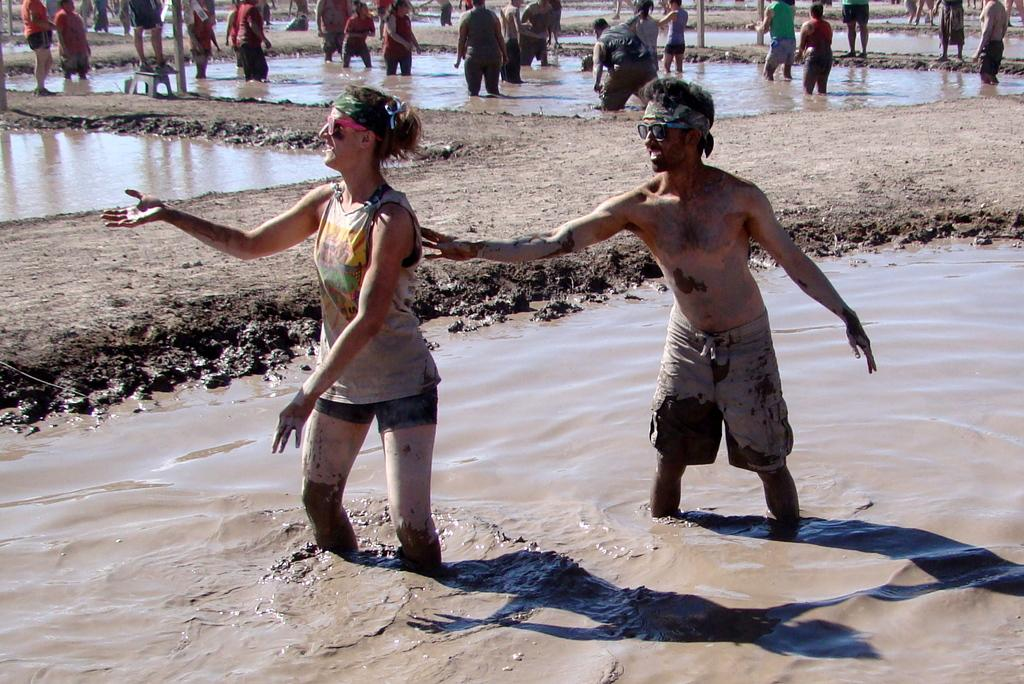What are the people in the image doing? The people in the image are standing in the mud. How can you describe the clothing of the people in the image? The people are wearing different color dresses. What accessory are the people wearing in the image? The people are wearing glasses. What can be seen in the background of the image? There is water visible in the image. What objects are present in the image besides the people? There are poles and a stool in the image. What type of vacation is the group planning in the image? There is no indication in the image that the people are planning a vacation. What is the source of love in the image? There is no mention of love or any related subject in the image. 